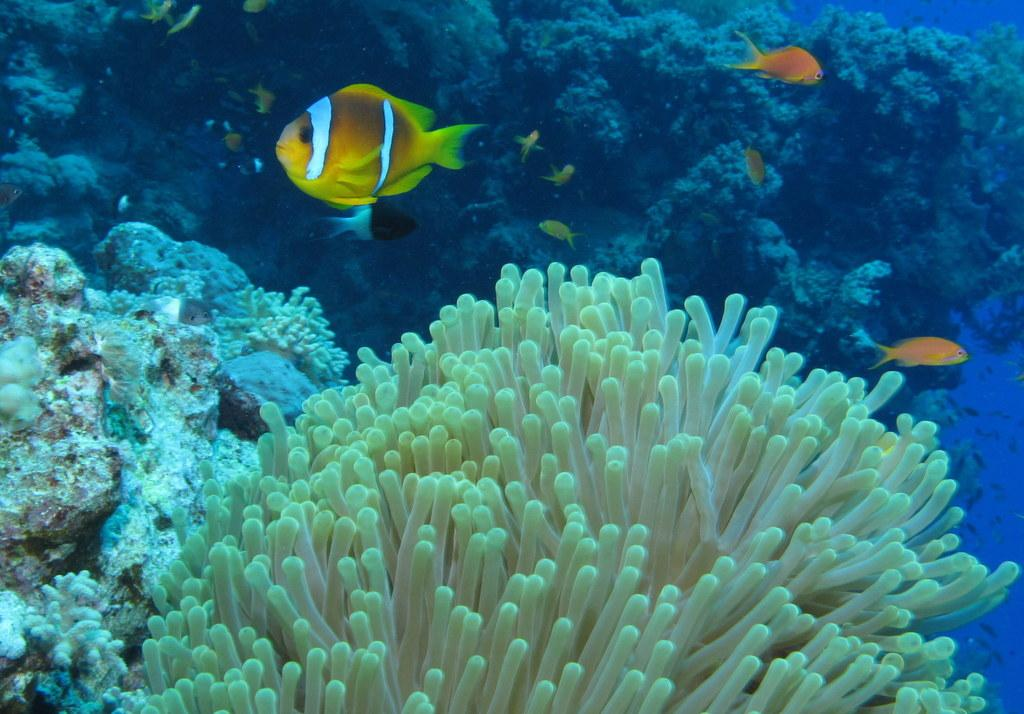What is the setting of the image? The image is taken underwater. What type of marine life can be seen in the image? There are fishes in the image. What other underwater features are present in the image? Underwater plants and rocks are visible in the image. How many legs can be seen on the fishes in the image? Fishes do not have legs; they have fins for swimming. 